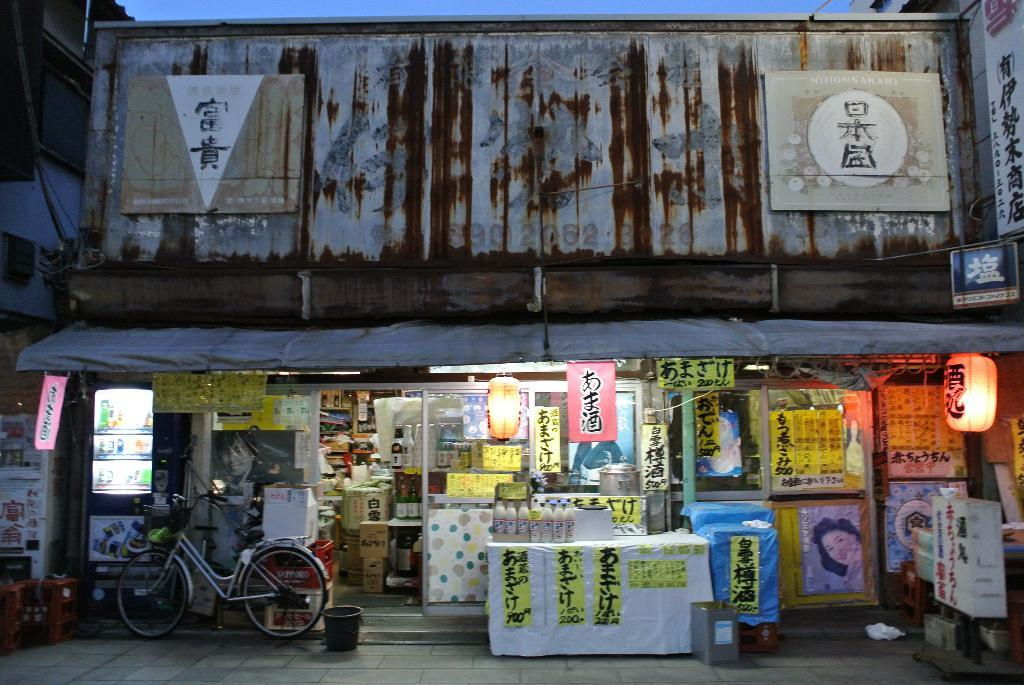<image>
Give a short and clear explanation of the subsequent image. Vertical yellow banners on a white table have the numbers 900 and 200 on them. 